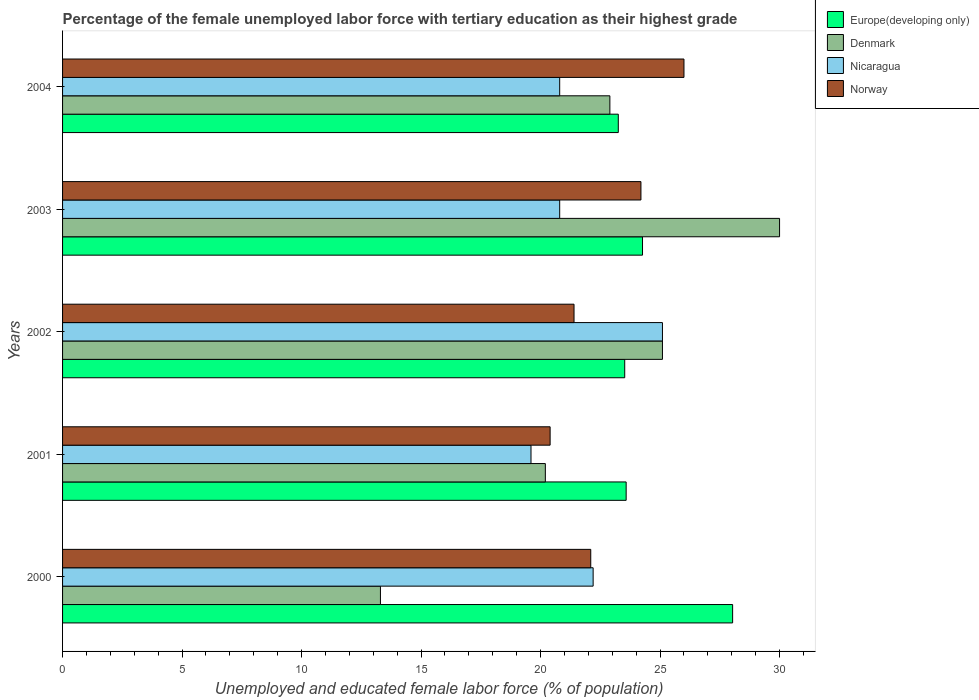How many bars are there on the 2nd tick from the bottom?
Your response must be concise. 4. What is the percentage of the unemployed female labor force with tertiary education in Nicaragua in 2000?
Ensure brevity in your answer.  22.2. Across all years, what is the maximum percentage of the unemployed female labor force with tertiary education in Europe(developing only)?
Give a very brief answer. 28.04. Across all years, what is the minimum percentage of the unemployed female labor force with tertiary education in Europe(developing only)?
Ensure brevity in your answer.  23.25. In which year was the percentage of the unemployed female labor force with tertiary education in Nicaragua minimum?
Offer a very short reply. 2001. What is the total percentage of the unemployed female labor force with tertiary education in Europe(developing only) in the graph?
Your response must be concise. 122.66. What is the difference between the percentage of the unemployed female labor force with tertiary education in Norway in 2001 and that in 2003?
Provide a short and direct response. -3.8. What is the difference between the percentage of the unemployed female labor force with tertiary education in Norway in 2000 and the percentage of the unemployed female labor force with tertiary education in Denmark in 2001?
Offer a terse response. 1.9. What is the average percentage of the unemployed female labor force with tertiary education in Europe(developing only) per year?
Offer a terse response. 24.53. In the year 2002, what is the difference between the percentage of the unemployed female labor force with tertiary education in Denmark and percentage of the unemployed female labor force with tertiary education in Norway?
Ensure brevity in your answer.  3.7. What is the ratio of the percentage of the unemployed female labor force with tertiary education in Europe(developing only) in 2000 to that in 2002?
Offer a terse response. 1.19. What is the difference between the highest and the second highest percentage of the unemployed female labor force with tertiary education in Nicaragua?
Offer a very short reply. 2.9. What is the difference between the highest and the lowest percentage of the unemployed female labor force with tertiary education in Norway?
Your answer should be compact. 5.6. Are all the bars in the graph horizontal?
Give a very brief answer. Yes. How many years are there in the graph?
Offer a terse response. 5. Are the values on the major ticks of X-axis written in scientific E-notation?
Provide a short and direct response. No. Does the graph contain any zero values?
Give a very brief answer. No. Does the graph contain grids?
Give a very brief answer. No. How many legend labels are there?
Provide a short and direct response. 4. How are the legend labels stacked?
Provide a short and direct response. Vertical. What is the title of the graph?
Your answer should be compact. Percentage of the female unemployed labor force with tertiary education as their highest grade. Does "Liechtenstein" appear as one of the legend labels in the graph?
Make the answer very short. No. What is the label or title of the X-axis?
Offer a very short reply. Unemployed and educated female labor force (% of population). What is the Unemployed and educated female labor force (% of population) of Europe(developing only) in 2000?
Make the answer very short. 28.04. What is the Unemployed and educated female labor force (% of population) in Denmark in 2000?
Offer a very short reply. 13.3. What is the Unemployed and educated female labor force (% of population) of Nicaragua in 2000?
Make the answer very short. 22.2. What is the Unemployed and educated female labor force (% of population) of Norway in 2000?
Your response must be concise. 22.1. What is the Unemployed and educated female labor force (% of population) in Europe(developing only) in 2001?
Your response must be concise. 23.58. What is the Unemployed and educated female labor force (% of population) of Denmark in 2001?
Offer a terse response. 20.2. What is the Unemployed and educated female labor force (% of population) in Nicaragua in 2001?
Provide a short and direct response. 19.6. What is the Unemployed and educated female labor force (% of population) of Norway in 2001?
Offer a terse response. 20.4. What is the Unemployed and educated female labor force (% of population) in Europe(developing only) in 2002?
Provide a short and direct response. 23.52. What is the Unemployed and educated female labor force (% of population) in Denmark in 2002?
Offer a very short reply. 25.1. What is the Unemployed and educated female labor force (% of population) of Nicaragua in 2002?
Ensure brevity in your answer.  25.1. What is the Unemployed and educated female labor force (% of population) of Norway in 2002?
Provide a short and direct response. 21.4. What is the Unemployed and educated female labor force (% of population) of Europe(developing only) in 2003?
Keep it short and to the point. 24.27. What is the Unemployed and educated female labor force (% of population) in Denmark in 2003?
Ensure brevity in your answer.  30. What is the Unemployed and educated female labor force (% of population) of Nicaragua in 2003?
Provide a short and direct response. 20.8. What is the Unemployed and educated female labor force (% of population) of Norway in 2003?
Keep it short and to the point. 24.2. What is the Unemployed and educated female labor force (% of population) in Europe(developing only) in 2004?
Offer a terse response. 23.25. What is the Unemployed and educated female labor force (% of population) in Denmark in 2004?
Offer a very short reply. 22.9. What is the Unemployed and educated female labor force (% of population) of Nicaragua in 2004?
Offer a terse response. 20.8. Across all years, what is the maximum Unemployed and educated female labor force (% of population) of Europe(developing only)?
Provide a succinct answer. 28.04. Across all years, what is the maximum Unemployed and educated female labor force (% of population) in Denmark?
Your response must be concise. 30. Across all years, what is the maximum Unemployed and educated female labor force (% of population) in Nicaragua?
Offer a terse response. 25.1. Across all years, what is the maximum Unemployed and educated female labor force (% of population) in Norway?
Your answer should be compact. 26. Across all years, what is the minimum Unemployed and educated female labor force (% of population) of Europe(developing only)?
Your answer should be compact. 23.25. Across all years, what is the minimum Unemployed and educated female labor force (% of population) in Denmark?
Ensure brevity in your answer.  13.3. Across all years, what is the minimum Unemployed and educated female labor force (% of population) in Nicaragua?
Ensure brevity in your answer.  19.6. Across all years, what is the minimum Unemployed and educated female labor force (% of population) in Norway?
Ensure brevity in your answer.  20.4. What is the total Unemployed and educated female labor force (% of population) of Europe(developing only) in the graph?
Give a very brief answer. 122.66. What is the total Unemployed and educated female labor force (% of population) of Denmark in the graph?
Make the answer very short. 111.5. What is the total Unemployed and educated female labor force (% of population) in Nicaragua in the graph?
Your response must be concise. 108.5. What is the total Unemployed and educated female labor force (% of population) of Norway in the graph?
Offer a terse response. 114.1. What is the difference between the Unemployed and educated female labor force (% of population) of Europe(developing only) in 2000 and that in 2001?
Offer a terse response. 4.46. What is the difference between the Unemployed and educated female labor force (% of population) in Europe(developing only) in 2000 and that in 2002?
Keep it short and to the point. 4.51. What is the difference between the Unemployed and educated female labor force (% of population) in Denmark in 2000 and that in 2002?
Offer a very short reply. -11.8. What is the difference between the Unemployed and educated female labor force (% of population) of Nicaragua in 2000 and that in 2002?
Offer a very short reply. -2.9. What is the difference between the Unemployed and educated female labor force (% of population) of Europe(developing only) in 2000 and that in 2003?
Offer a terse response. 3.77. What is the difference between the Unemployed and educated female labor force (% of population) of Denmark in 2000 and that in 2003?
Your answer should be compact. -16.7. What is the difference between the Unemployed and educated female labor force (% of population) of Europe(developing only) in 2000 and that in 2004?
Provide a succinct answer. 4.78. What is the difference between the Unemployed and educated female labor force (% of population) in Denmark in 2000 and that in 2004?
Your response must be concise. -9.6. What is the difference between the Unemployed and educated female labor force (% of population) of Nicaragua in 2000 and that in 2004?
Offer a very short reply. 1.4. What is the difference between the Unemployed and educated female labor force (% of population) of Europe(developing only) in 2001 and that in 2003?
Give a very brief answer. -0.68. What is the difference between the Unemployed and educated female labor force (% of population) in Nicaragua in 2001 and that in 2003?
Offer a very short reply. -1.2. What is the difference between the Unemployed and educated female labor force (% of population) of Europe(developing only) in 2001 and that in 2004?
Make the answer very short. 0.33. What is the difference between the Unemployed and educated female labor force (% of population) of Nicaragua in 2001 and that in 2004?
Give a very brief answer. -1.2. What is the difference between the Unemployed and educated female labor force (% of population) of Norway in 2001 and that in 2004?
Your answer should be compact. -5.6. What is the difference between the Unemployed and educated female labor force (% of population) of Europe(developing only) in 2002 and that in 2003?
Your answer should be very brief. -0.74. What is the difference between the Unemployed and educated female labor force (% of population) in Denmark in 2002 and that in 2003?
Make the answer very short. -4.9. What is the difference between the Unemployed and educated female labor force (% of population) of Norway in 2002 and that in 2003?
Provide a short and direct response. -2.8. What is the difference between the Unemployed and educated female labor force (% of population) of Europe(developing only) in 2002 and that in 2004?
Make the answer very short. 0.27. What is the difference between the Unemployed and educated female labor force (% of population) of Norway in 2002 and that in 2004?
Provide a succinct answer. -4.6. What is the difference between the Unemployed and educated female labor force (% of population) in Europe(developing only) in 2003 and that in 2004?
Provide a short and direct response. 1.01. What is the difference between the Unemployed and educated female labor force (% of population) of Denmark in 2003 and that in 2004?
Your response must be concise. 7.1. What is the difference between the Unemployed and educated female labor force (% of population) in Nicaragua in 2003 and that in 2004?
Make the answer very short. 0. What is the difference between the Unemployed and educated female labor force (% of population) in Europe(developing only) in 2000 and the Unemployed and educated female labor force (% of population) in Denmark in 2001?
Provide a succinct answer. 7.84. What is the difference between the Unemployed and educated female labor force (% of population) in Europe(developing only) in 2000 and the Unemployed and educated female labor force (% of population) in Nicaragua in 2001?
Provide a short and direct response. 8.44. What is the difference between the Unemployed and educated female labor force (% of population) of Europe(developing only) in 2000 and the Unemployed and educated female labor force (% of population) of Norway in 2001?
Ensure brevity in your answer.  7.64. What is the difference between the Unemployed and educated female labor force (% of population) of Denmark in 2000 and the Unemployed and educated female labor force (% of population) of Nicaragua in 2001?
Ensure brevity in your answer.  -6.3. What is the difference between the Unemployed and educated female labor force (% of population) in Europe(developing only) in 2000 and the Unemployed and educated female labor force (% of population) in Denmark in 2002?
Keep it short and to the point. 2.94. What is the difference between the Unemployed and educated female labor force (% of population) of Europe(developing only) in 2000 and the Unemployed and educated female labor force (% of population) of Nicaragua in 2002?
Keep it short and to the point. 2.94. What is the difference between the Unemployed and educated female labor force (% of population) of Europe(developing only) in 2000 and the Unemployed and educated female labor force (% of population) of Norway in 2002?
Make the answer very short. 6.64. What is the difference between the Unemployed and educated female labor force (% of population) in Denmark in 2000 and the Unemployed and educated female labor force (% of population) in Nicaragua in 2002?
Your response must be concise. -11.8. What is the difference between the Unemployed and educated female labor force (% of population) in Europe(developing only) in 2000 and the Unemployed and educated female labor force (% of population) in Denmark in 2003?
Keep it short and to the point. -1.96. What is the difference between the Unemployed and educated female labor force (% of population) in Europe(developing only) in 2000 and the Unemployed and educated female labor force (% of population) in Nicaragua in 2003?
Provide a succinct answer. 7.24. What is the difference between the Unemployed and educated female labor force (% of population) in Europe(developing only) in 2000 and the Unemployed and educated female labor force (% of population) in Norway in 2003?
Offer a very short reply. 3.84. What is the difference between the Unemployed and educated female labor force (% of population) of Europe(developing only) in 2000 and the Unemployed and educated female labor force (% of population) of Denmark in 2004?
Your answer should be very brief. 5.14. What is the difference between the Unemployed and educated female labor force (% of population) in Europe(developing only) in 2000 and the Unemployed and educated female labor force (% of population) in Nicaragua in 2004?
Offer a very short reply. 7.24. What is the difference between the Unemployed and educated female labor force (% of population) in Europe(developing only) in 2000 and the Unemployed and educated female labor force (% of population) in Norway in 2004?
Provide a short and direct response. 2.04. What is the difference between the Unemployed and educated female labor force (% of population) in Denmark in 2000 and the Unemployed and educated female labor force (% of population) in Nicaragua in 2004?
Ensure brevity in your answer.  -7.5. What is the difference between the Unemployed and educated female labor force (% of population) of Europe(developing only) in 2001 and the Unemployed and educated female labor force (% of population) of Denmark in 2002?
Provide a short and direct response. -1.52. What is the difference between the Unemployed and educated female labor force (% of population) of Europe(developing only) in 2001 and the Unemployed and educated female labor force (% of population) of Nicaragua in 2002?
Offer a terse response. -1.52. What is the difference between the Unemployed and educated female labor force (% of population) of Europe(developing only) in 2001 and the Unemployed and educated female labor force (% of population) of Norway in 2002?
Provide a short and direct response. 2.18. What is the difference between the Unemployed and educated female labor force (% of population) of Denmark in 2001 and the Unemployed and educated female labor force (% of population) of Norway in 2002?
Your answer should be compact. -1.2. What is the difference between the Unemployed and educated female labor force (% of population) in Europe(developing only) in 2001 and the Unemployed and educated female labor force (% of population) in Denmark in 2003?
Make the answer very short. -6.42. What is the difference between the Unemployed and educated female labor force (% of population) in Europe(developing only) in 2001 and the Unemployed and educated female labor force (% of population) in Nicaragua in 2003?
Offer a very short reply. 2.78. What is the difference between the Unemployed and educated female labor force (% of population) of Europe(developing only) in 2001 and the Unemployed and educated female labor force (% of population) of Norway in 2003?
Ensure brevity in your answer.  -0.62. What is the difference between the Unemployed and educated female labor force (% of population) of Nicaragua in 2001 and the Unemployed and educated female labor force (% of population) of Norway in 2003?
Offer a very short reply. -4.6. What is the difference between the Unemployed and educated female labor force (% of population) in Europe(developing only) in 2001 and the Unemployed and educated female labor force (% of population) in Denmark in 2004?
Your answer should be compact. 0.68. What is the difference between the Unemployed and educated female labor force (% of population) in Europe(developing only) in 2001 and the Unemployed and educated female labor force (% of population) in Nicaragua in 2004?
Your answer should be compact. 2.78. What is the difference between the Unemployed and educated female labor force (% of population) of Europe(developing only) in 2001 and the Unemployed and educated female labor force (% of population) of Norway in 2004?
Offer a terse response. -2.42. What is the difference between the Unemployed and educated female labor force (% of population) of Europe(developing only) in 2002 and the Unemployed and educated female labor force (% of population) of Denmark in 2003?
Your answer should be very brief. -6.48. What is the difference between the Unemployed and educated female labor force (% of population) in Europe(developing only) in 2002 and the Unemployed and educated female labor force (% of population) in Nicaragua in 2003?
Your response must be concise. 2.72. What is the difference between the Unemployed and educated female labor force (% of population) of Europe(developing only) in 2002 and the Unemployed and educated female labor force (% of population) of Norway in 2003?
Provide a short and direct response. -0.68. What is the difference between the Unemployed and educated female labor force (% of population) of Europe(developing only) in 2002 and the Unemployed and educated female labor force (% of population) of Denmark in 2004?
Give a very brief answer. 0.62. What is the difference between the Unemployed and educated female labor force (% of population) of Europe(developing only) in 2002 and the Unemployed and educated female labor force (% of population) of Nicaragua in 2004?
Provide a short and direct response. 2.72. What is the difference between the Unemployed and educated female labor force (% of population) in Europe(developing only) in 2002 and the Unemployed and educated female labor force (% of population) in Norway in 2004?
Your answer should be very brief. -2.48. What is the difference between the Unemployed and educated female labor force (% of population) of Nicaragua in 2002 and the Unemployed and educated female labor force (% of population) of Norway in 2004?
Ensure brevity in your answer.  -0.9. What is the difference between the Unemployed and educated female labor force (% of population) of Europe(developing only) in 2003 and the Unemployed and educated female labor force (% of population) of Denmark in 2004?
Make the answer very short. 1.37. What is the difference between the Unemployed and educated female labor force (% of population) of Europe(developing only) in 2003 and the Unemployed and educated female labor force (% of population) of Nicaragua in 2004?
Provide a short and direct response. 3.47. What is the difference between the Unemployed and educated female labor force (% of population) in Europe(developing only) in 2003 and the Unemployed and educated female labor force (% of population) in Norway in 2004?
Give a very brief answer. -1.73. What is the difference between the Unemployed and educated female labor force (% of population) in Denmark in 2003 and the Unemployed and educated female labor force (% of population) in Nicaragua in 2004?
Your answer should be very brief. 9.2. What is the average Unemployed and educated female labor force (% of population) of Europe(developing only) per year?
Provide a short and direct response. 24.53. What is the average Unemployed and educated female labor force (% of population) in Denmark per year?
Your response must be concise. 22.3. What is the average Unemployed and educated female labor force (% of population) of Nicaragua per year?
Offer a terse response. 21.7. What is the average Unemployed and educated female labor force (% of population) in Norway per year?
Give a very brief answer. 22.82. In the year 2000, what is the difference between the Unemployed and educated female labor force (% of population) in Europe(developing only) and Unemployed and educated female labor force (% of population) in Denmark?
Offer a very short reply. 14.74. In the year 2000, what is the difference between the Unemployed and educated female labor force (% of population) in Europe(developing only) and Unemployed and educated female labor force (% of population) in Nicaragua?
Make the answer very short. 5.84. In the year 2000, what is the difference between the Unemployed and educated female labor force (% of population) of Europe(developing only) and Unemployed and educated female labor force (% of population) of Norway?
Provide a short and direct response. 5.94. In the year 2000, what is the difference between the Unemployed and educated female labor force (% of population) of Denmark and Unemployed and educated female labor force (% of population) of Norway?
Offer a terse response. -8.8. In the year 2001, what is the difference between the Unemployed and educated female labor force (% of population) of Europe(developing only) and Unemployed and educated female labor force (% of population) of Denmark?
Keep it short and to the point. 3.38. In the year 2001, what is the difference between the Unemployed and educated female labor force (% of population) of Europe(developing only) and Unemployed and educated female labor force (% of population) of Nicaragua?
Keep it short and to the point. 3.98. In the year 2001, what is the difference between the Unemployed and educated female labor force (% of population) in Europe(developing only) and Unemployed and educated female labor force (% of population) in Norway?
Offer a very short reply. 3.18. In the year 2001, what is the difference between the Unemployed and educated female labor force (% of population) of Nicaragua and Unemployed and educated female labor force (% of population) of Norway?
Provide a succinct answer. -0.8. In the year 2002, what is the difference between the Unemployed and educated female labor force (% of population) of Europe(developing only) and Unemployed and educated female labor force (% of population) of Denmark?
Keep it short and to the point. -1.58. In the year 2002, what is the difference between the Unemployed and educated female labor force (% of population) of Europe(developing only) and Unemployed and educated female labor force (% of population) of Nicaragua?
Your answer should be compact. -1.58. In the year 2002, what is the difference between the Unemployed and educated female labor force (% of population) of Europe(developing only) and Unemployed and educated female labor force (% of population) of Norway?
Make the answer very short. 2.12. In the year 2002, what is the difference between the Unemployed and educated female labor force (% of population) of Denmark and Unemployed and educated female labor force (% of population) of Norway?
Provide a succinct answer. 3.7. In the year 2002, what is the difference between the Unemployed and educated female labor force (% of population) in Nicaragua and Unemployed and educated female labor force (% of population) in Norway?
Provide a succinct answer. 3.7. In the year 2003, what is the difference between the Unemployed and educated female labor force (% of population) of Europe(developing only) and Unemployed and educated female labor force (% of population) of Denmark?
Provide a short and direct response. -5.73. In the year 2003, what is the difference between the Unemployed and educated female labor force (% of population) in Europe(developing only) and Unemployed and educated female labor force (% of population) in Nicaragua?
Offer a very short reply. 3.47. In the year 2003, what is the difference between the Unemployed and educated female labor force (% of population) of Europe(developing only) and Unemployed and educated female labor force (% of population) of Norway?
Your response must be concise. 0.07. In the year 2003, what is the difference between the Unemployed and educated female labor force (% of population) of Denmark and Unemployed and educated female labor force (% of population) of Norway?
Offer a very short reply. 5.8. In the year 2003, what is the difference between the Unemployed and educated female labor force (% of population) of Nicaragua and Unemployed and educated female labor force (% of population) of Norway?
Provide a short and direct response. -3.4. In the year 2004, what is the difference between the Unemployed and educated female labor force (% of population) of Europe(developing only) and Unemployed and educated female labor force (% of population) of Denmark?
Make the answer very short. 0.35. In the year 2004, what is the difference between the Unemployed and educated female labor force (% of population) of Europe(developing only) and Unemployed and educated female labor force (% of population) of Nicaragua?
Offer a terse response. 2.45. In the year 2004, what is the difference between the Unemployed and educated female labor force (% of population) in Europe(developing only) and Unemployed and educated female labor force (% of population) in Norway?
Provide a succinct answer. -2.75. In the year 2004, what is the difference between the Unemployed and educated female labor force (% of population) of Denmark and Unemployed and educated female labor force (% of population) of Nicaragua?
Give a very brief answer. 2.1. In the year 2004, what is the difference between the Unemployed and educated female labor force (% of population) in Denmark and Unemployed and educated female labor force (% of population) in Norway?
Your response must be concise. -3.1. What is the ratio of the Unemployed and educated female labor force (% of population) in Europe(developing only) in 2000 to that in 2001?
Offer a terse response. 1.19. What is the ratio of the Unemployed and educated female labor force (% of population) in Denmark in 2000 to that in 2001?
Provide a short and direct response. 0.66. What is the ratio of the Unemployed and educated female labor force (% of population) of Nicaragua in 2000 to that in 2001?
Give a very brief answer. 1.13. What is the ratio of the Unemployed and educated female labor force (% of population) of Europe(developing only) in 2000 to that in 2002?
Provide a succinct answer. 1.19. What is the ratio of the Unemployed and educated female labor force (% of population) of Denmark in 2000 to that in 2002?
Offer a very short reply. 0.53. What is the ratio of the Unemployed and educated female labor force (% of population) of Nicaragua in 2000 to that in 2002?
Provide a succinct answer. 0.88. What is the ratio of the Unemployed and educated female labor force (% of population) of Norway in 2000 to that in 2002?
Your answer should be very brief. 1.03. What is the ratio of the Unemployed and educated female labor force (% of population) in Europe(developing only) in 2000 to that in 2003?
Offer a terse response. 1.16. What is the ratio of the Unemployed and educated female labor force (% of population) of Denmark in 2000 to that in 2003?
Offer a terse response. 0.44. What is the ratio of the Unemployed and educated female labor force (% of population) in Nicaragua in 2000 to that in 2003?
Your response must be concise. 1.07. What is the ratio of the Unemployed and educated female labor force (% of population) of Norway in 2000 to that in 2003?
Give a very brief answer. 0.91. What is the ratio of the Unemployed and educated female labor force (% of population) of Europe(developing only) in 2000 to that in 2004?
Give a very brief answer. 1.21. What is the ratio of the Unemployed and educated female labor force (% of population) of Denmark in 2000 to that in 2004?
Offer a terse response. 0.58. What is the ratio of the Unemployed and educated female labor force (% of population) of Nicaragua in 2000 to that in 2004?
Offer a very short reply. 1.07. What is the ratio of the Unemployed and educated female labor force (% of population) in Europe(developing only) in 2001 to that in 2002?
Keep it short and to the point. 1. What is the ratio of the Unemployed and educated female labor force (% of population) in Denmark in 2001 to that in 2002?
Offer a very short reply. 0.8. What is the ratio of the Unemployed and educated female labor force (% of population) in Nicaragua in 2001 to that in 2002?
Provide a succinct answer. 0.78. What is the ratio of the Unemployed and educated female labor force (% of population) in Norway in 2001 to that in 2002?
Your answer should be very brief. 0.95. What is the ratio of the Unemployed and educated female labor force (% of population) in Europe(developing only) in 2001 to that in 2003?
Provide a short and direct response. 0.97. What is the ratio of the Unemployed and educated female labor force (% of population) in Denmark in 2001 to that in 2003?
Provide a short and direct response. 0.67. What is the ratio of the Unemployed and educated female labor force (% of population) of Nicaragua in 2001 to that in 2003?
Give a very brief answer. 0.94. What is the ratio of the Unemployed and educated female labor force (% of population) of Norway in 2001 to that in 2003?
Offer a terse response. 0.84. What is the ratio of the Unemployed and educated female labor force (% of population) of Europe(developing only) in 2001 to that in 2004?
Offer a very short reply. 1.01. What is the ratio of the Unemployed and educated female labor force (% of population) in Denmark in 2001 to that in 2004?
Ensure brevity in your answer.  0.88. What is the ratio of the Unemployed and educated female labor force (% of population) of Nicaragua in 2001 to that in 2004?
Your answer should be very brief. 0.94. What is the ratio of the Unemployed and educated female labor force (% of population) of Norway in 2001 to that in 2004?
Offer a terse response. 0.78. What is the ratio of the Unemployed and educated female labor force (% of population) in Europe(developing only) in 2002 to that in 2003?
Offer a terse response. 0.97. What is the ratio of the Unemployed and educated female labor force (% of population) of Denmark in 2002 to that in 2003?
Your response must be concise. 0.84. What is the ratio of the Unemployed and educated female labor force (% of population) of Nicaragua in 2002 to that in 2003?
Your answer should be very brief. 1.21. What is the ratio of the Unemployed and educated female labor force (% of population) in Norway in 2002 to that in 2003?
Give a very brief answer. 0.88. What is the ratio of the Unemployed and educated female labor force (% of population) of Europe(developing only) in 2002 to that in 2004?
Offer a terse response. 1.01. What is the ratio of the Unemployed and educated female labor force (% of population) in Denmark in 2002 to that in 2004?
Keep it short and to the point. 1.1. What is the ratio of the Unemployed and educated female labor force (% of population) of Nicaragua in 2002 to that in 2004?
Your answer should be very brief. 1.21. What is the ratio of the Unemployed and educated female labor force (% of population) of Norway in 2002 to that in 2004?
Keep it short and to the point. 0.82. What is the ratio of the Unemployed and educated female labor force (% of population) in Europe(developing only) in 2003 to that in 2004?
Your response must be concise. 1.04. What is the ratio of the Unemployed and educated female labor force (% of population) of Denmark in 2003 to that in 2004?
Make the answer very short. 1.31. What is the ratio of the Unemployed and educated female labor force (% of population) in Nicaragua in 2003 to that in 2004?
Keep it short and to the point. 1. What is the ratio of the Unemployed and educated female labor force (% of population) in Norway in 2003 to that in 2004?
Your answer should be very brief. 0.93. What is the difference between the highest and the second highest Unemployed and educated female labor force (% of population) in Europe(developing only)?
Ensure brevity in your answer.  3.77. What is the difference between the highest and the second highest Unemployed and educated female labor force (% of population) in Nicaragua?
Make the answer very short. 2.9. What is the difference between the highest and the second highest Unemployed and educated female labor force (% of population) of Norway?
Give a very brief answer. 1.8. What is the difference between the highest and the lowest Unemployed and educated female labor force (% of population) in Europe(developing only)?
Make the answer very short. 4.78. What is the difference between the highest and the lowest Unemployed and educated female labor force (% of population) of Nicaragua?
Offer a very short reply. 5.5. What is the difference between the highest and the lowest Unemployed and educated female labor force (% of population) of Norway?
Give a very brief answer. 5.6. 